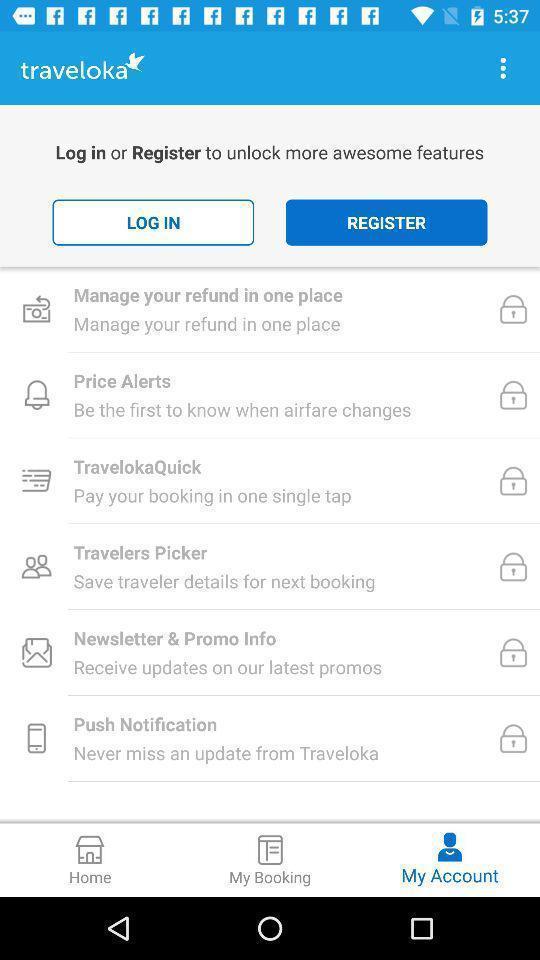Describe the key features of this screenshot. Page displaying to login for more features. 